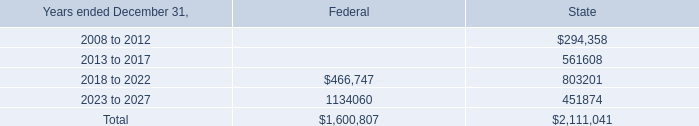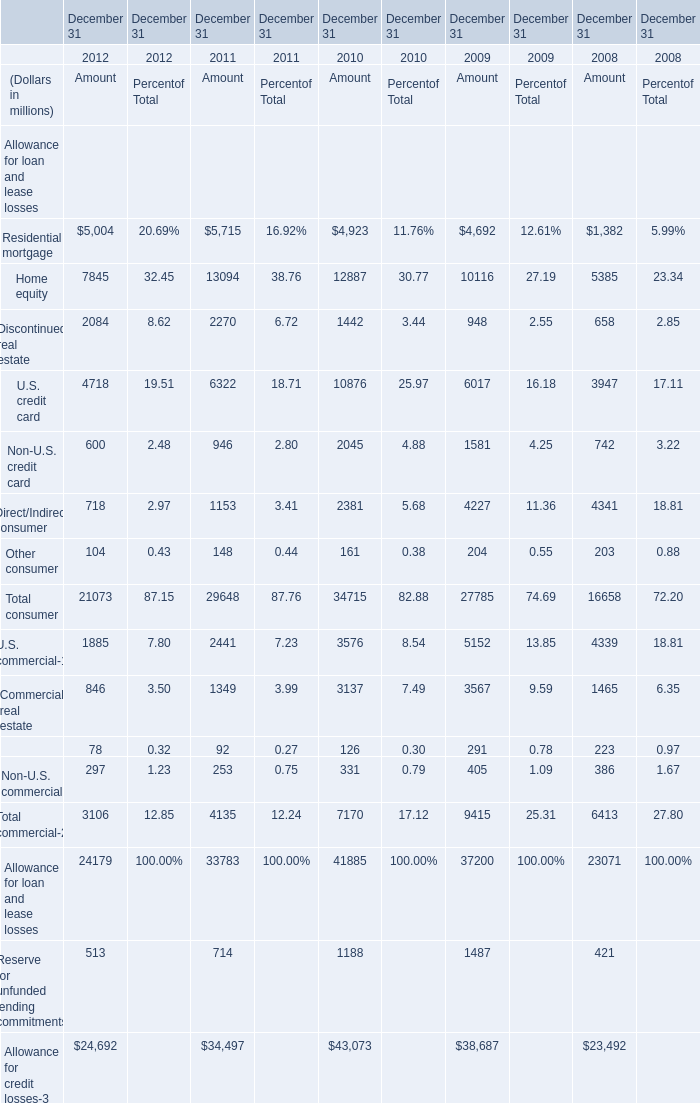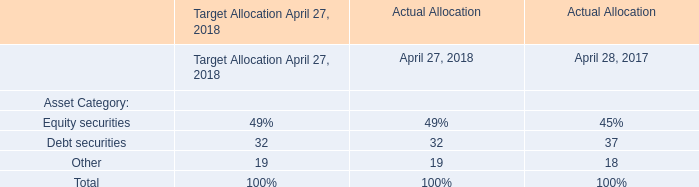If Home equity for Amout develops with the same growth rate in 2011, what will it reach in 2012? (in million) 
Computations: (13094 * (1 + ((13094 - 12887) / 12887)))
Answer: 13304.32498. 